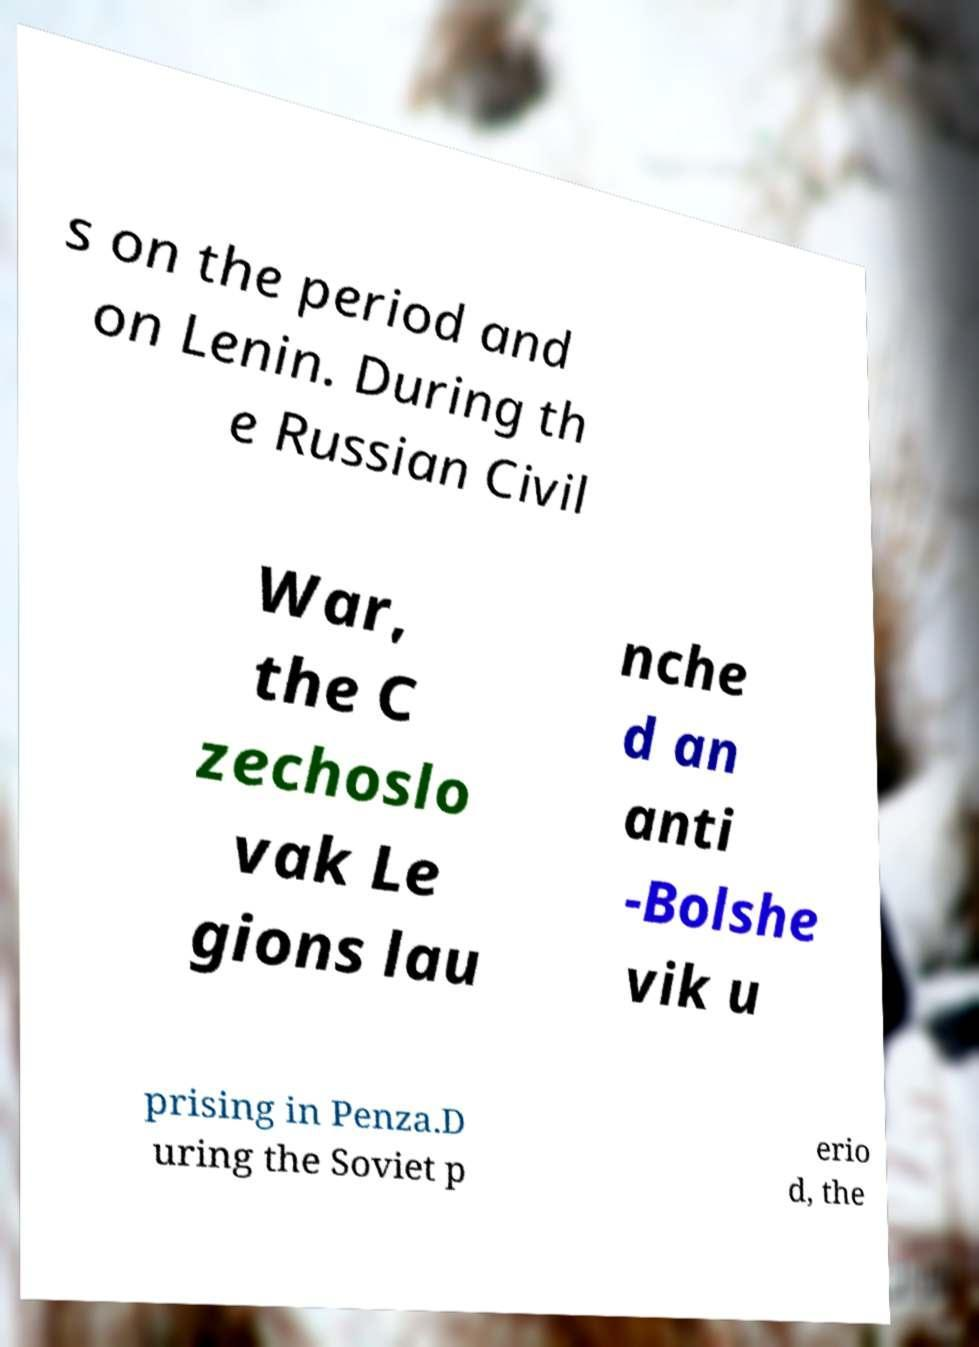There's text embedded in this image that I need extracted. Can you transcribe it verbatim? s on the period and on Lenin. During th e Russian Civil War, the C zechoslo vak Le gions lau nche d an anti -Bolshe vik u prising in Penza.D uring the Soviet p erio d, the 